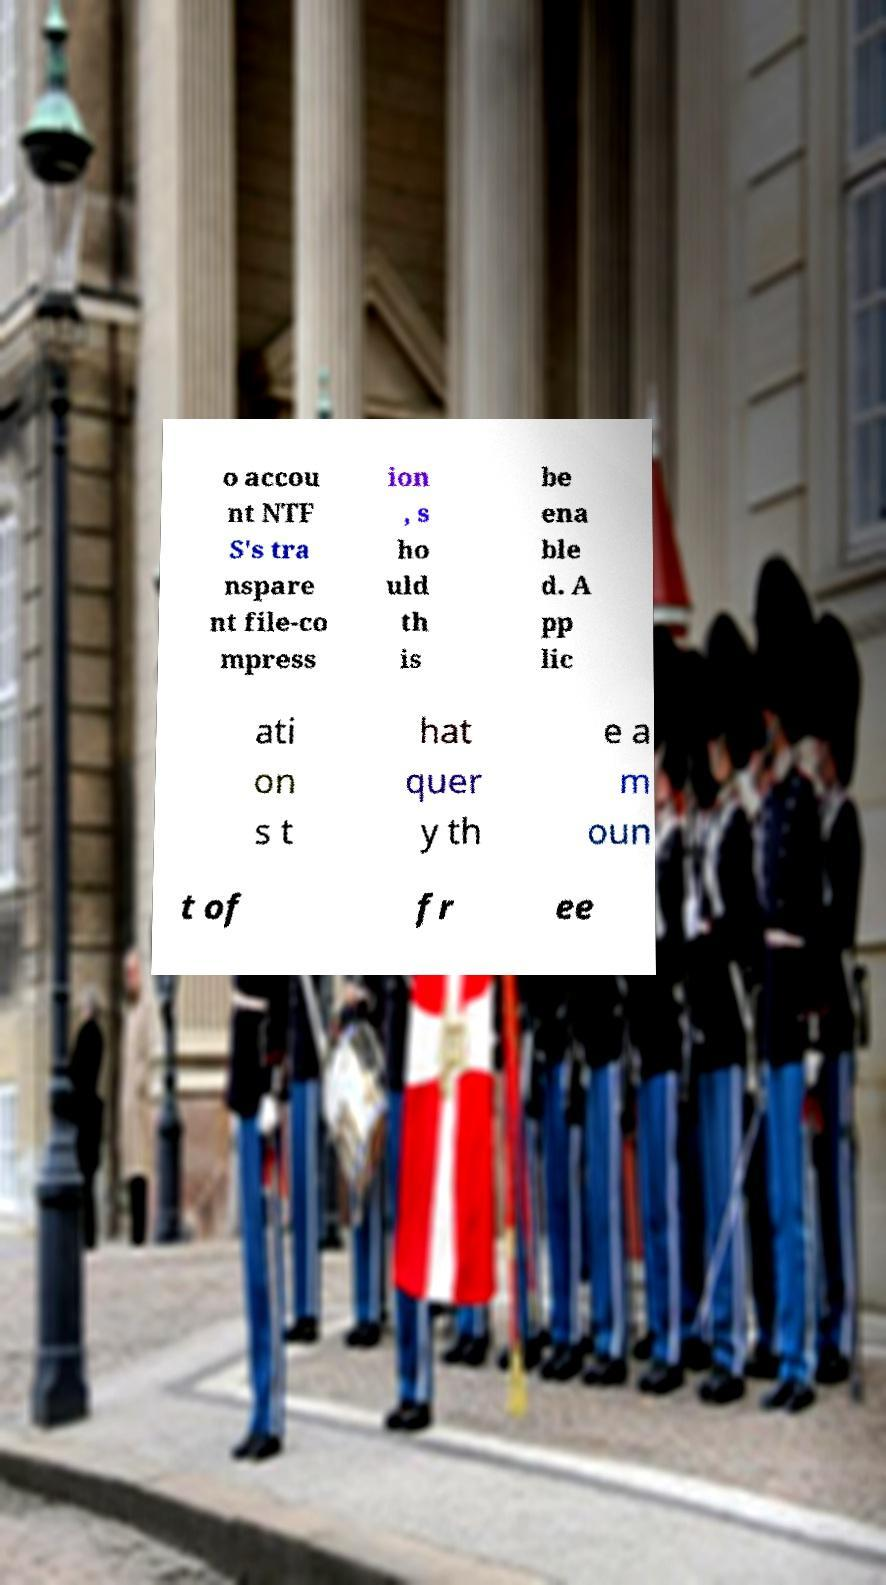Please read and relay the text visible in this image. What does it say? o accou nt NTF S's tra nspare nt file-co mpress ion , s ho uld th is be ena ble d. A pp lic ati on s t hat quer y th e a m oun t of fr ee 